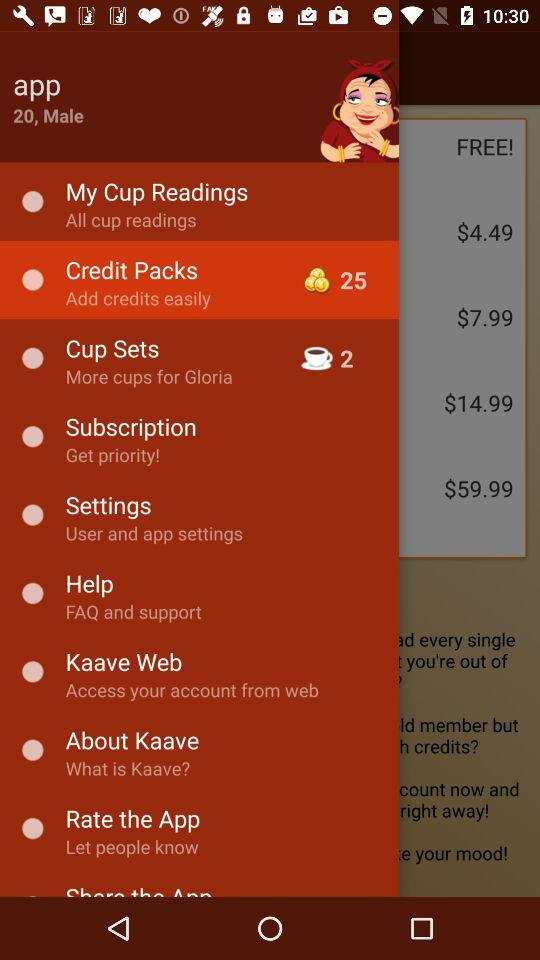What is the profile name? The profile name is App. 